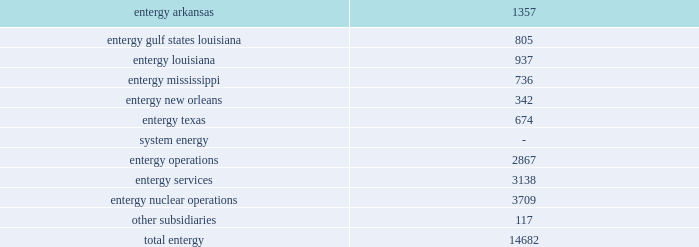Part i item 1 entergy corporation , utility operating companies , and system energy asbestos litigation ( entergy arkansas , entergy gulf states louisiana , entergy louisiana , entergy mississippi , entergy new orleans , and entergy texas ) numerous lawsuits have been filed in federal and state courts primarily in texas and louisiana , primarily by contractor employees who worked in the 1940-1980s timeframe , against entergy gulf states louisiana and entergy texas , and to a lesser extent the other utility operating companies , as premises owners of power plants , for damages caused by alleged exposure to asbestos .
Many other defendants are named in these lawsuits as well .
Currently , there are approximately 500 lawsuits involving approximately 5000 claimants .
Management believes that adequate provisions have been established to cover any exposure .
Additionally , negotiations continue with insurers to recover reimbursements .
Management believes that loss exposure has been and will continue to be handled so that the ultimate resolution of these matters will not be material , in the aggregate , to the financial position or results of operation of the utility operating companies .
Employment and labor-related proceedings ( entergy corporation , entergy arkansas , entergy gulf states louisiana , entergy louisiana , entergy mississippi , entergy new orleans , entergy texas , and system energy ) the registrant subsidiaries and other entergy subsidiaries are responding to various lawsuits in both state and federal courts and to other labor-related proceedings filed by current and former employees .
Generally , the amount of damages being sought is not specified in these proceedings .
These actions include , but are not limited to , allegations of wrongful employment actions ; wage disputes and other claims under the fair labor standards act or its state counterparts ; claims of race , gender and disability discrimination ; disputes arising under collective bargaining agreements ; unfair labor practice proceedings and other administrative proceedings before the national labor relations board ; claims of retaliation ; and claims for or regarding benefits under various entergy corporation sponsored plans .
Entergy and the registrant subsidiaries are responding to these suits and proceedings and deny liability to the claimants .
Employees employees are an integral part of entergy 2019s commitment to serving customers .
As of december 31 , 2011 , entergy subsidiaries employed 14682 people .
Utility: .
Approximately 5300 employees are represented by the international brotherhood of electrical workers , the utility workers union of america , the international brotherhood of teamsters , the united government security officers of america , and the international union , security , police , fire professionals of america. .
What percentage of total entergy's employees are part of entergy arkansas? 
Computations: (1357 / 14682)
Answer: 0.09243. 